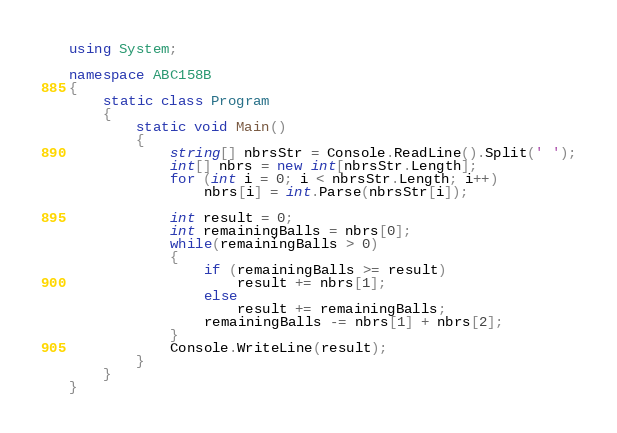<code> <loc_0><loc_0><loc_500><loc_500><_C#_>using System;

namespace ABC158B
{
    static class Program
    {
        static void Main()
        {
            string[] nbrsStr = Console.ReadLine().Split(' ');
            int[] nbrs = new int[nbrsStr.Length];
            for (int i = 0; i < nbrsStr.Length; i++)
                nbrs[i] = int.Parse(nbrsStr[i]);

            int result = 0;
            int remainingBalls = nbrs[0];
            while(remainingBalls > 0)
            {
                if (remainingBalls >= result)
                    result += nbrs[1];
                else
                    result += remainingBalls;
                remainingBalls -= nbrs[1] + nbrs[2];
            }
            Console.WriteLine(result);
        }
    }
}</code> 